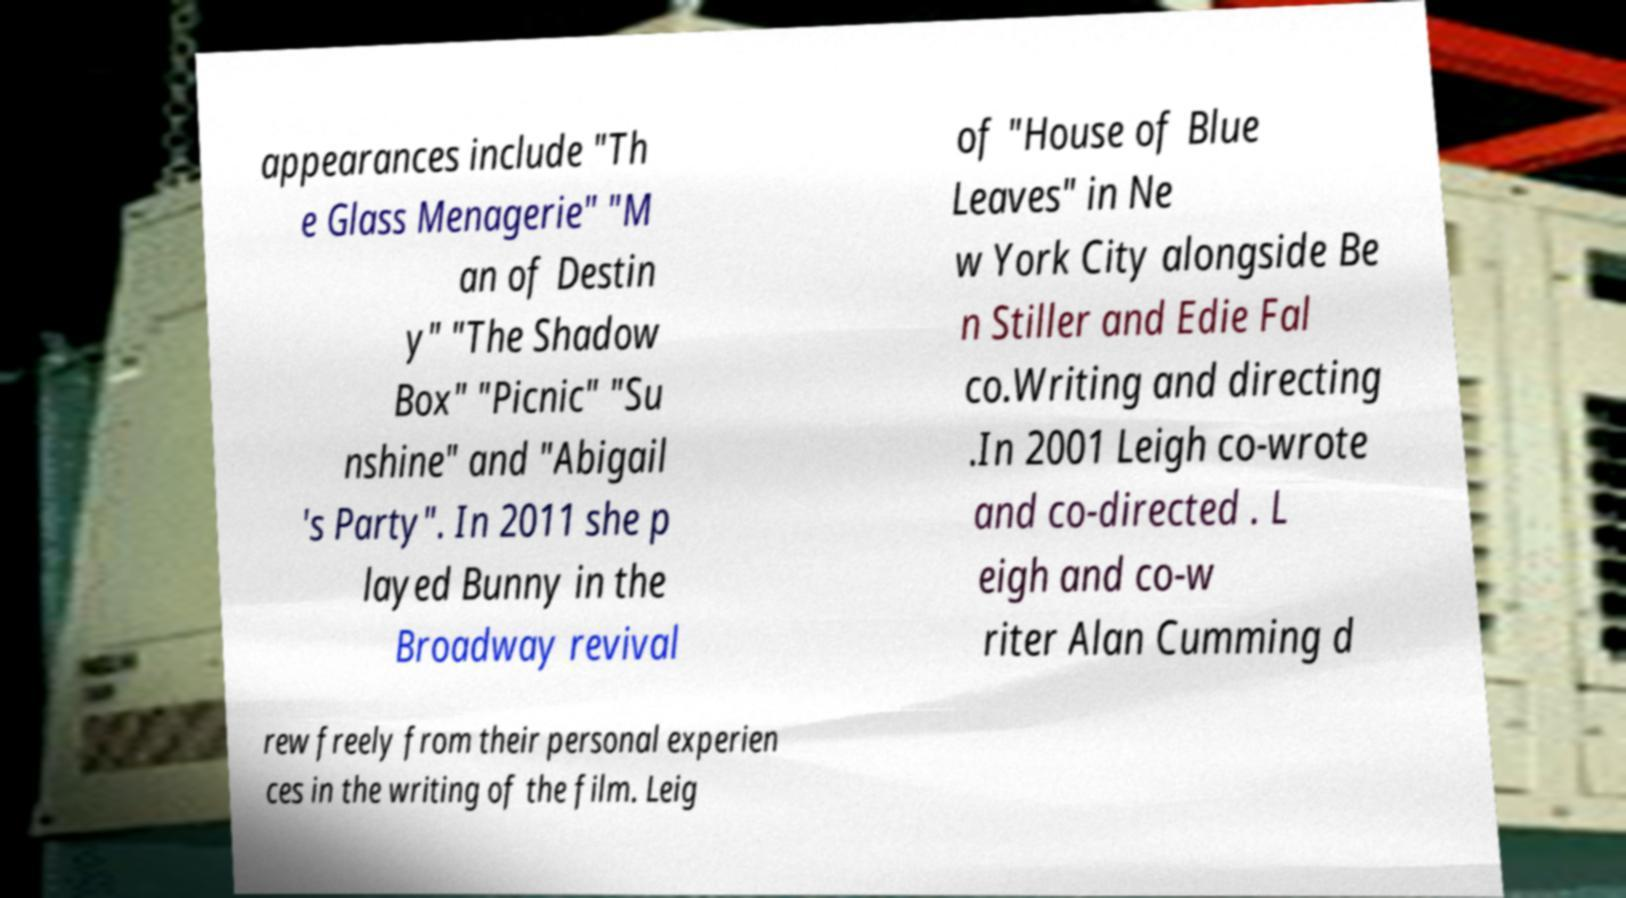Could you extract and type out the text from this image? appearances include "Th e Glass Menagerie" "M an of Destin y" "The Shadow Box" "Picnic" "Su nshine" and "Abigail 's Party". In 2011 she p layed Bunny in the Broadway revival of "House of Blue Leaves" in Ne w York City alongside Be n Stiller and Edie Fal co.Writing and directing .In 2001 Leigh co-wrote and co-directed . L eigh and co-w riter Alan Cumming d rew freely from their personal experien ces in the writing of the film. Leig 